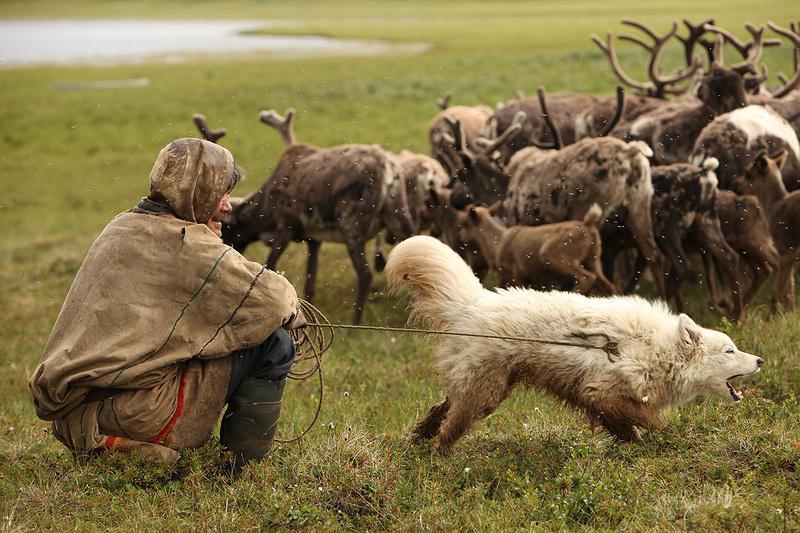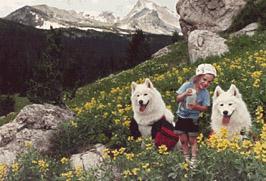The first image is the image on the left, the second image is the image on the right. Analyze the images presented: Is the assertion "There is a dog herding sheep and one woman in each image" valid? Answer yes or no. No. The first image is the image on the left, the second image is the image on the right. Examine the images to the left and right. Is the description "A girl wearing a blue sweatshirt is with a white dog and some sheep." accurate? Answer yes or no. No. 